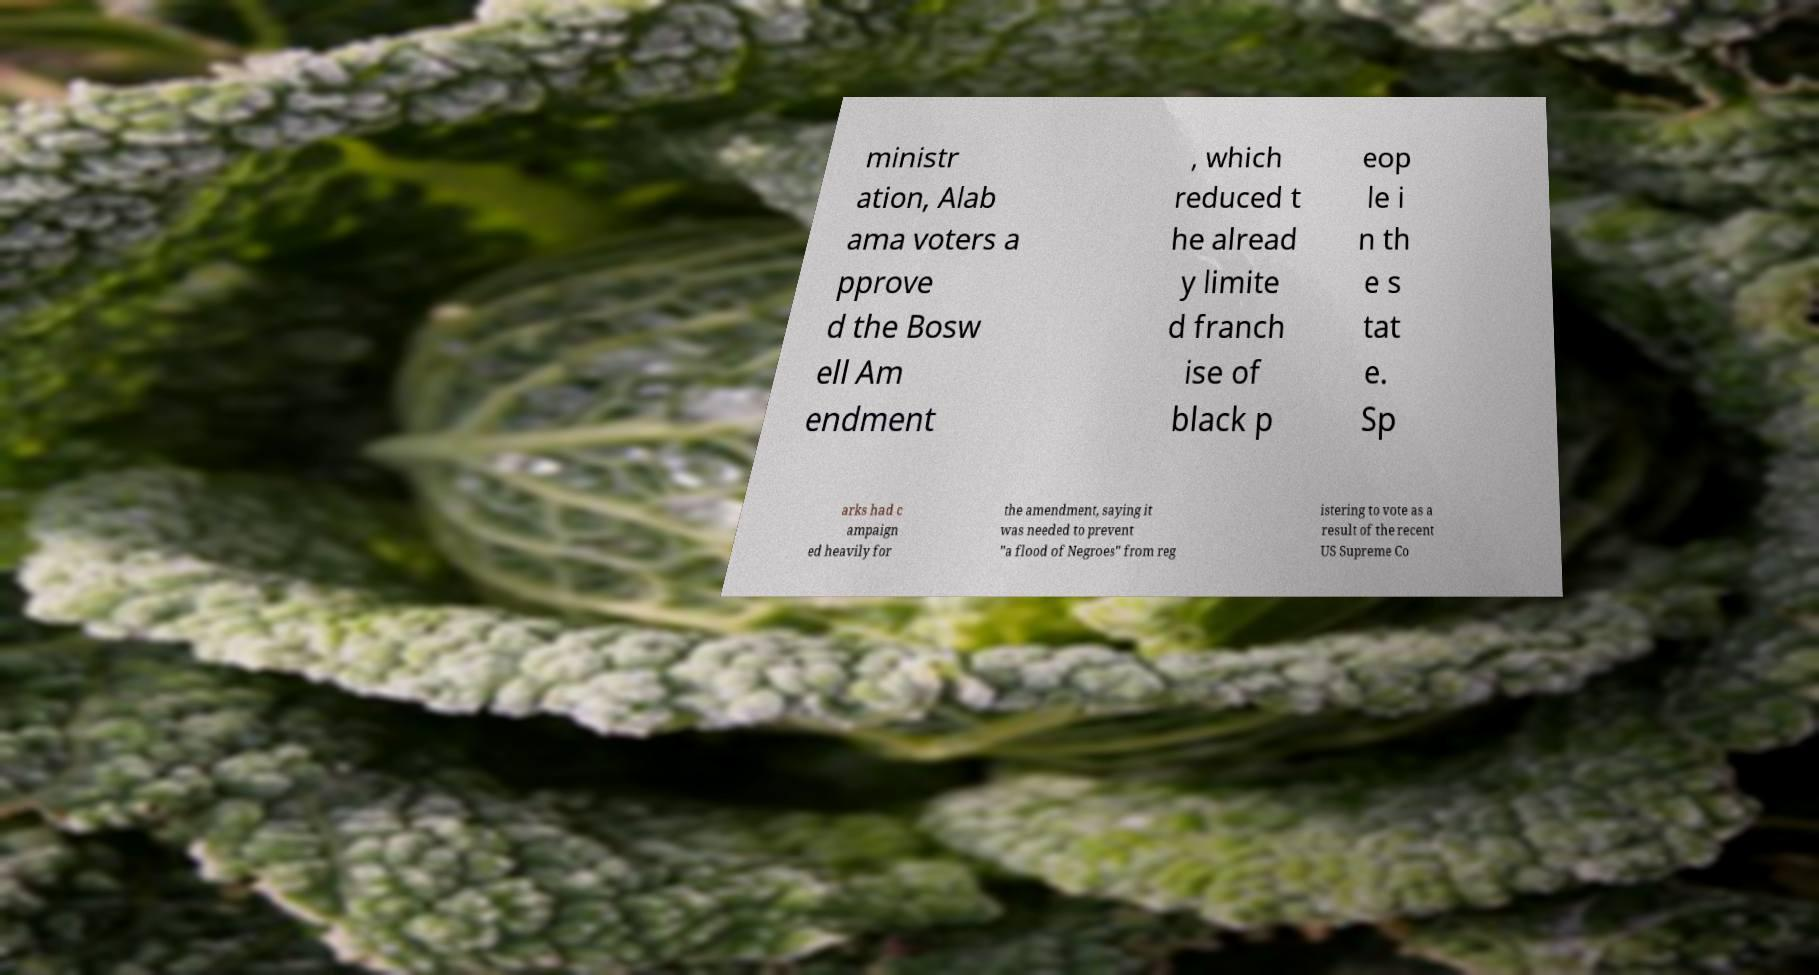Can you accurately transcribe the text from the provided image for me? ministr ation, Alab ama voters a pprove d the Bosw ell Am endment , which reduced t he alread y limite d franch ise of black p eop le i n th e s tat e. Sp arks had c ampaign ed heavily for the amendment, saying it was needed to prevent "a flood of Negroes" from reg istering to vote as a result of the recent US Supreme Co 